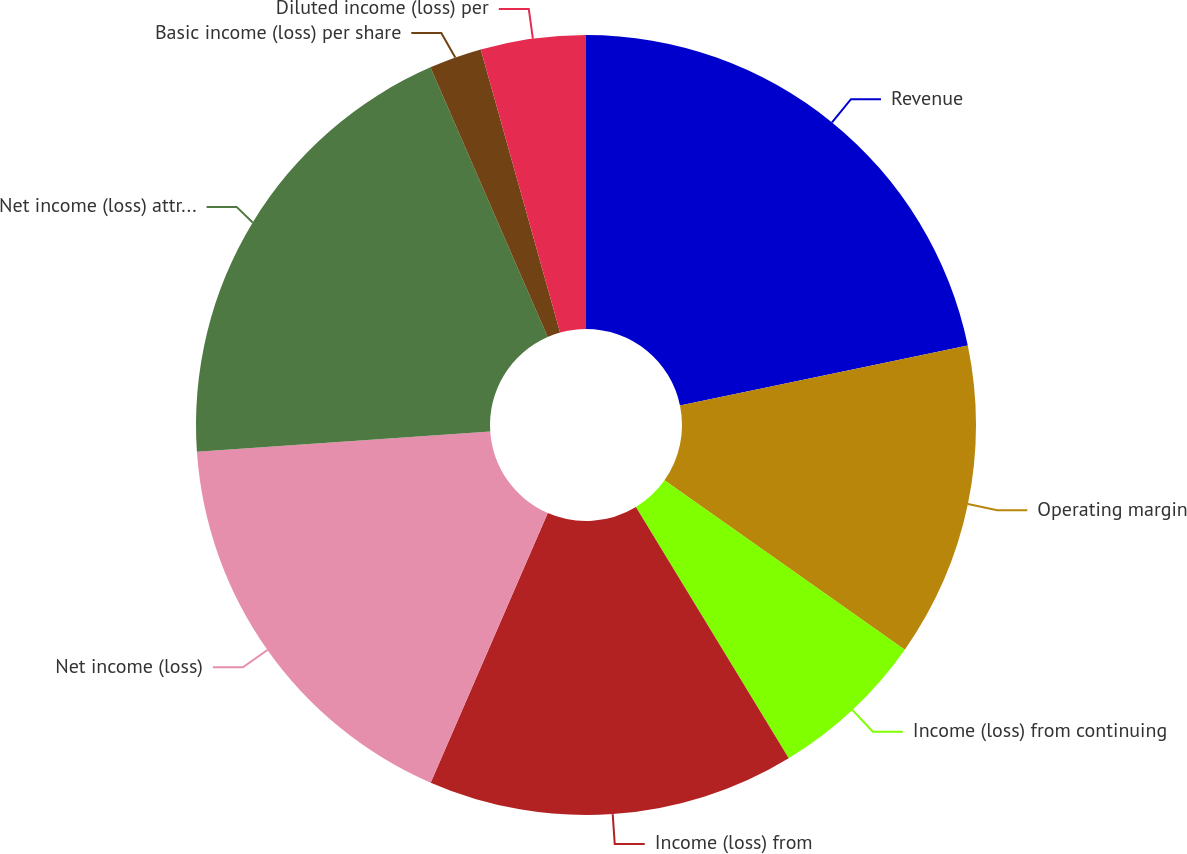Convert chart. <chart><loc_0><loc_0><loc_500><loc_500><pie_chart><fcel>Revenue<fcel>Operating margin<fcel>Income (loss) from continuing<fcel>Income (loss) from<fcel>Net income (loss)<fcel>Net income (loss) attributable<fcel>Basic income (loss) per share<fcel>Diluted income (loss) per<nl><fcel>21.73%<fcel>13.04%<fcel>6.53%<fcel>15.22%<fcel>17.39%<fcel>19.56%<fcel>2.18%<fcel>4.35%<nl></chart> 